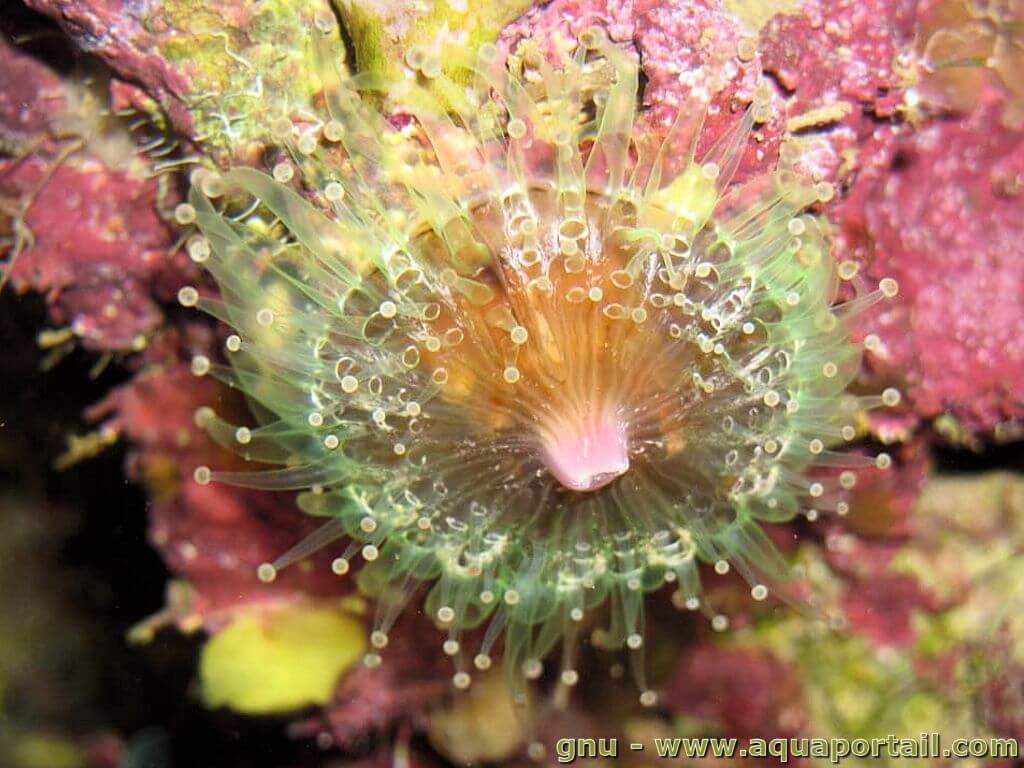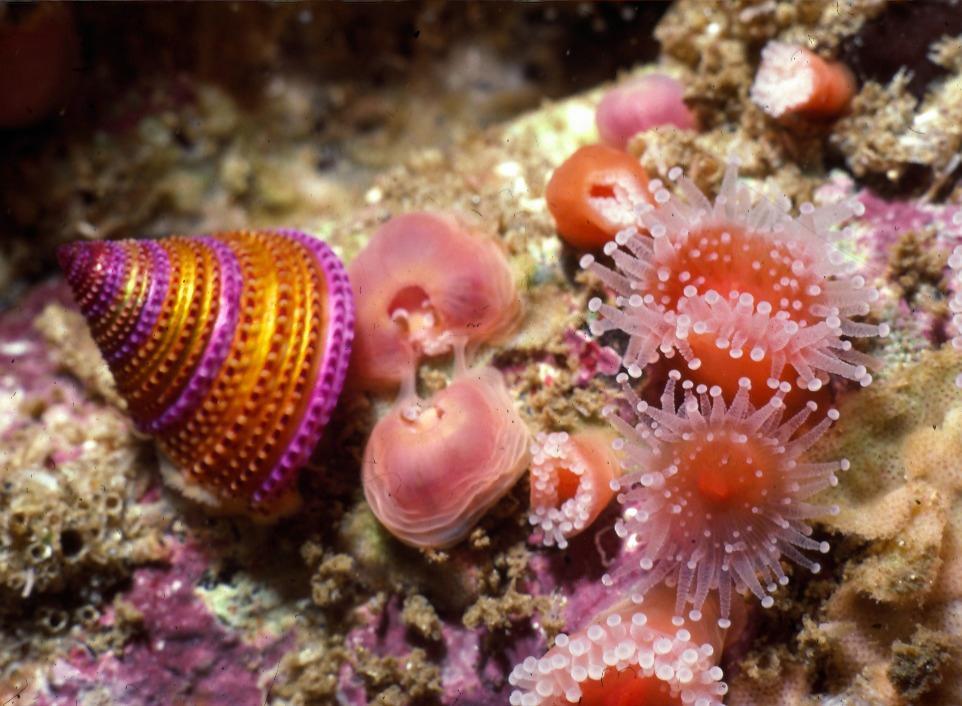The first image is the image on the left, the second image is the image on the right. Considering the images on both sides, is "In the image to the left, the creature clearly has a green tint to it." valid? Answer yes or no. Yes. 